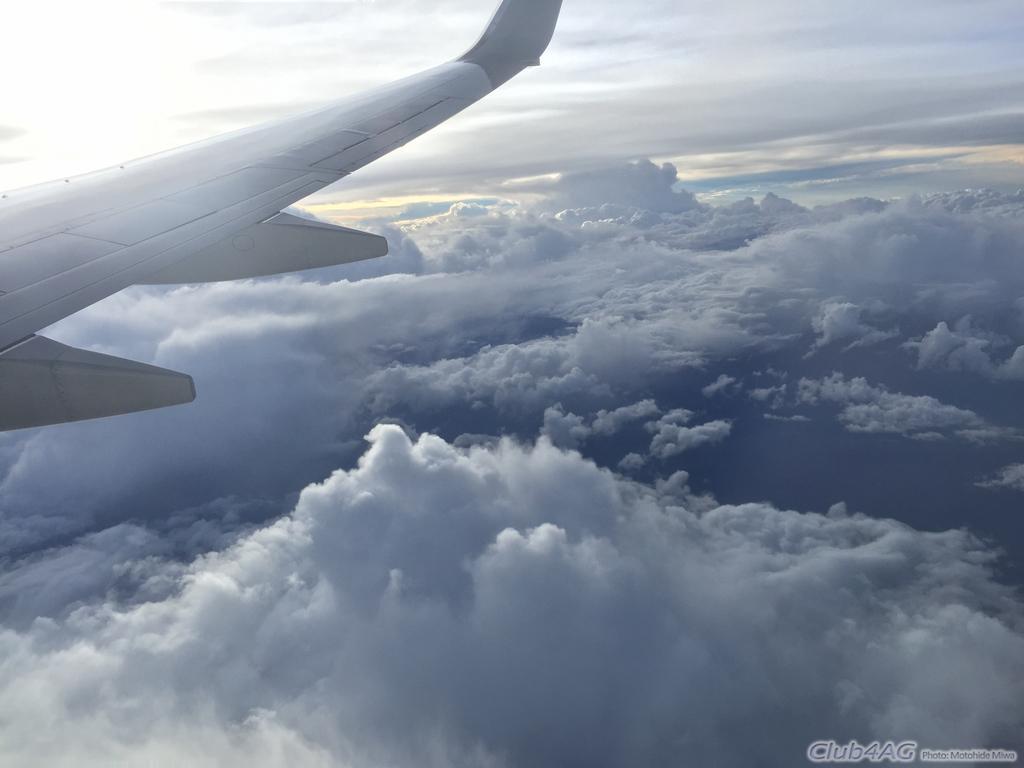Describe this image in one or two sentences. In this picture we can see an airplane on the left side, in the background we can see the sky and clouds, at the right bottom there is some text. 